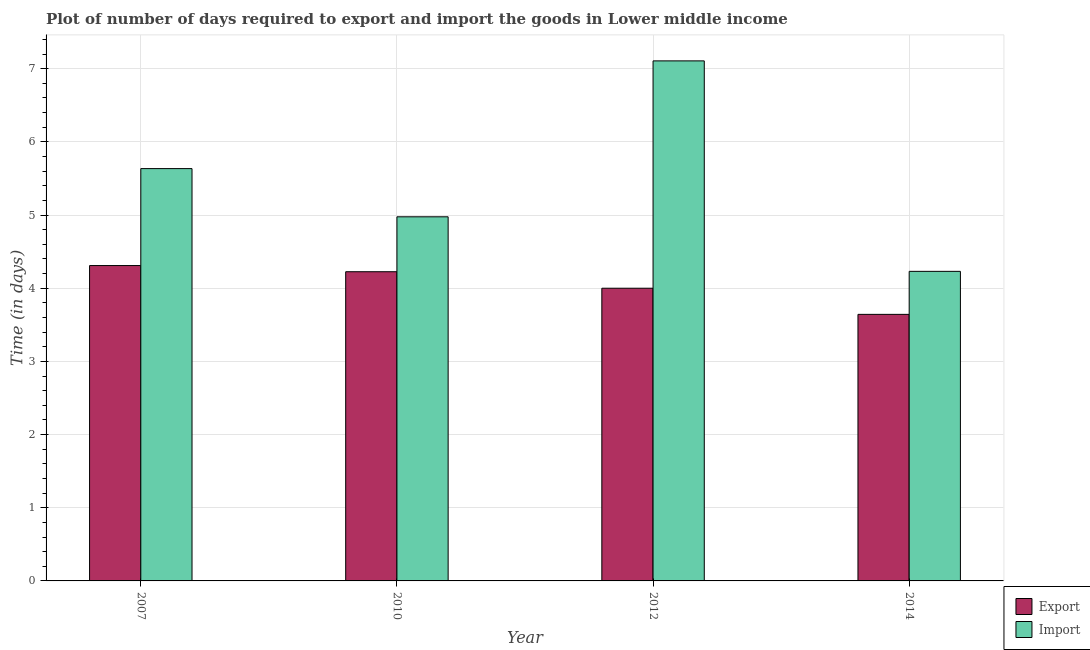How many different coloured bars are there?
Keep it short and to the point. 2. How many bars are there on the 1st tick from the left?
Provide a short and direct response. 2. How many bars are there on the 4th tick from the right?
Keep it short and to the point. 2. What is the label of the 2nd group of bars from the left?
Offer a very short reply. 2010. What is the time required to import in 2014?
Offer a terse response. 4.23. Across all years, what is the maximum time required to import?
Offer a very short reply. 7.11. Across all years, what is the minimum time required to import?
Your response must be concise. 4.23. In which year was the time required to import maximum?
Make the answer very short. 2012. What is the total time required to import in the graph?
Keep it short and to the point. 21.95. What is the difference between the time required to export in 2007 and that in 2014?
Provide a succinct answer. 0.67. What is the difference between the time required to import in 2012 and the time required to export in 2010?
Your response must be concise. 2.13. What is the average time required to export per year?
Offer a very short reply. 4.04. In the year 2014, what is the difference between the time required to import and time required to export?
Ensure brevity in your answer.  0. In how many years, is the time required to import greater than 2 days?
Give a very brief answer. 4. What is the ratio of the time required to export in 2012 to that in 2014?
Offer a terse response. 1.1. Is the difference between the time required to export in 2007 and 2012 greater than the difference between the time required to import in 2007 and 2012?
Provide a succinct answer. No. What is the difference between the highest and the second highest time required to import?
Your answer should be compact. 1.47. What is the difference between the highest and the lowest time required to import?
Ensure brevity in your answer.  2.88. Is the sum of the time required to export in 2010 and 2012 greater than the maximum time required to import across all years?
Ensure brevity in your answer.  Yes. What does the 2nd bar from the left in 2007 represents?
Give a very brief answer. Import. What does the 2nd bar from the right in 2012 represents?
Make the answer very short. Export. How many bars are there?
Make the answer very short. 8. What is the difference between two consecutive major ticks on the Y-axis?
Provide a short and direct response. 1. Are the values on the major ticks of Y-axis written in scientific E-notation?
Make the answer very short. No. Does the graph contain any zero values?
Offer a terse response. No. How are the legend labels stacked?
Offer a terse response. Vertical. What is the title of the graph?
Your answer should be compact. Plot of number of days required to export and import the goods in Lower middle income. Does "Services" appear as one of the legend labels in the graph?
Give a very brief answer. No. What is the label or title of the X-axis?
Your response must be concise. Year. What is the label or title of the Y-axis?
Ensure brevity in your answer.  Time (in days). What is the Time (in days) of Export in 2007?
Offer a very short reply. 4.31. What is the Time (in days) in Import in 2007?
Provide a short and direct response. 5.63. What is the Time (in days) in Export in 2010?
Keep it short and to the point. 4.23. What is the Time (in days) in Import in 2010?
Your answer should be very brief. 4.98. What is the Time (in days) of Import in 2012?
Make the answer very short. 7.11. What is the Time (in days) of Export in 2014?
Offer a very short reply. 3.64. What is the Time (in days) in Import in 2014?
Ensure brevity in your answer.  4.23. Across all years, what is the maximum Time (in days) in Export?
Your answer should be very brief. 4.31. Across all years, what is the maximum Time (in days) in Import?
Your answer should be very brief. 7.11. Across all years, what is the minimum Time (in days) in Export?
Ensure brevity in your answer.  3.64. Across all years, what is the minimum Time (in days) in Import?
Keep it short and to the point. 4.23. What is the total Time (in days) in Export in the graph?
Offer a very short reply. 16.18. What is the total Time (in days) in Import in the graph?
Give a very brief answer. 21.95. What is the difference between the Time (in days) of Export in 2007 and that in 2010?
Make the answer very short. 0.08. What is the difference between the Time (in days) in Import in 2007 and that in 2010?
Your response must be concise. 0.66. What is the difference between the Time (in days) of Export in 2007 and that in 2012?
Keep it short and to the point. 0.31. What is the difference between the Time (in days) of Import in 2007 and that in 2012?
Your answer should be very brief. -1.47. What is the difference between the Time (in days) in Export in 2007 and that in 2014?
Keep it short and to the point. 0.67. What is the difference between the Time (in days) of Import in 2007 and that in 2014?
Give a very brief answer. 1.4. What is the difference between the Time (in days) of Export in 2010 and that in 2012?
Provide a short and direct response. 0.23. What is the difference between the Time (in days) in Import in 2010 and that in 2012?
Give a very brief answer. -2.13. What is the difference between the Time (in days) of Export in 2010 and that in 2014?
Offer a terse response. 0.58. What is the difference between the Time (in days) of Import in 2010 and that in 2014?
Give a very brief answer. 0.75. What is the difference between the Time (in days) of Export in 2012 and that in 2014?
Make the answer very short. 0.36. What is the difference between the Time (in days) of Import in 2012 and that in 2014?
Offer a terse response. 2.88. What is the difference between the Time (in days) of Export in 2007 and the Time (in days) of Import in 2010?
Your response must be concise. -0.67. What is the difference between the Time (in days) of Export in 2007 and the Time (in days) of Import in 2012?
Keep it short and to the point. -2.8. What is the difference between the Time (in days) of Export in 2007 and the Time (in days) of Import in 2014?
Give a very brief answer. 0.08. What is the difference between the Time (in days) of Export in 2010 and the Time (in days) of Import in 2012?
Provide a short and direct response. -2.88. What is the difference between the Time (in days) of Export in 2010 and the Time (in days) of Import in 2014?
Your response must be concise. -0.01. What is the difference between the Time (in days) in Export in 2012 and the Time (in days) in Import in 2014?
Offer a very short reply. -0.23. What is the average Time (in days) in Export per year?
Your answer should be very brief. 4.04. What is the average Time (in days) in Import per year?
Provide a succinct answer. 5.49. In the year 2007, what is the difference between the Time (in days) of Export and Time (in days) of Import?
Your answer should be compact. -1.32. In the year 2010, what is the difference between the Time (in days) of Export and Time (in days) of Import?
Your response must be concise. -0.75. In the year 2012, what is the difference between the Time (in days) of Export and Time (in days) of Import?
Provide a short and direct response. -3.11. In the year 2014, what is the difference between the Time (in days) of Export and Time (in days) of Import?
Offer a terse response. -0.59. What is the ratio of the Time (in days) in Import in 2007 to that in 2010?
Your answer should be compact. 1.13. What is the ratio of the Time (in days) of Export in 2007 to that in 2012?
Your response must be concise. 1.08. What is the ratio of the Time (in days) of Import in 2007 to that in 2012?
Ensure brevity in your answer.  0.79. What is the ratio of the Time (in days) in Export in 2007 to that in 2014?
Your answer should be very brief. 1.18. What is the ratio of the Time (in days) of Import in 2007 to that in 2014?
Keep it short and to the point. 1.33. What is the ratio of the Time (in days) of Export in 2010 to that in 2012?
Provide a short and direct response. 1.06. What is the ratio of the Time (in days) of Import in 2010 to that in 2012?
Provide a short and direct response. 0.7. What is the ratio of the Time (in days) of Export in 2010 to that in 2014?
Your answer should be very brief. 1.16. What is the ratio of the Time (in days) in Import in 2010 to that in 2014?
Provide a succinct answer. 1.18. What is the ratio of the Time (in days) of Export in 2012 to that in 2014?
Provide a short and direct response. 1.1. What is the ratio of the Time (in days) in Import in 2012 to that in 2014?
Provide a succinct answer. 1.68. What is the difference between the highest and the second highest Time (in days) of Export?
Provide a succinct answer. 0.08. What is the difference between the highest and the second highest Time (in days) in Import?
Keep it short and to the point. 1.47. What is the difference between the highest and the lowest Time (in days) in Export?
Your answer should be very brief. 0.67. What is the difference between the highest and the lowest Time (in days) in Import?
Ensure brevity in your answer.  2.88. 